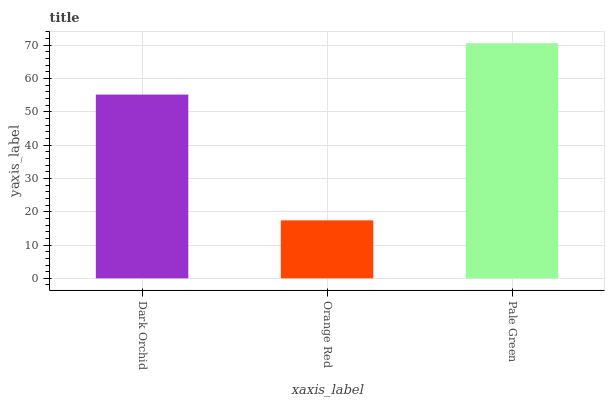Is Orange Red the minimum?
Answer yes or no. Yes. Is Pale Green the maximum?
Answer yes or no. Yes. Is Pale Green the minimum?
Answer yes or no. No. Is Orange Red the maximum?
Answer yes or no. No. Is Pale Green greater than Orange Red?
Answer yes or no. Yes. Is Orange Red less than Pale Green?
Answer yes or no. Yes. Is Orange Red greater than Pale Green?
Answer yes or no. No. Is Pale Green less than Orange Red?
Answer yes or no. No. Is Dark Orchid the high median?
Answer yes or no. Yes. Is Dark Orchid the low median?
Answer yes or no. Yes. Is Orange Red the high median?
Answer yes or no. No. Is Pale Green the low median?
Answer yes or no. No. 